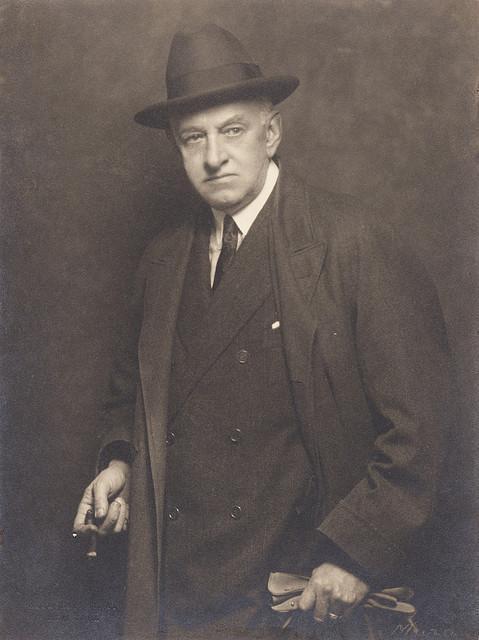How many people are in the photo?
Give a very brief answer. 1. How many thumbs are showing?
Give a very brief answer. 1. 